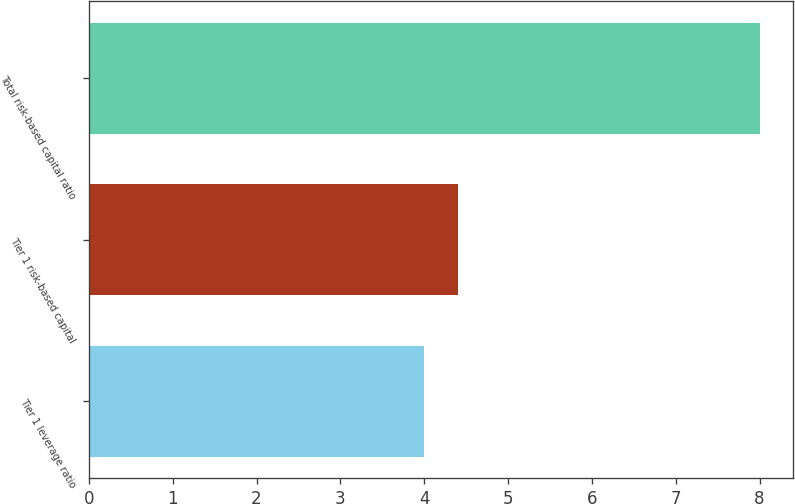Convert chart. <chart><loc_0><loc_0><loc_500><loc_500><bar_chart><fcel>Tier 1 leverage ratio<fcel>Tier 1 risk-based capital<fcel>Total risk-based capital ratio<nl><fcel>4<fcel>4.4<fcel>8<nl></chart> 